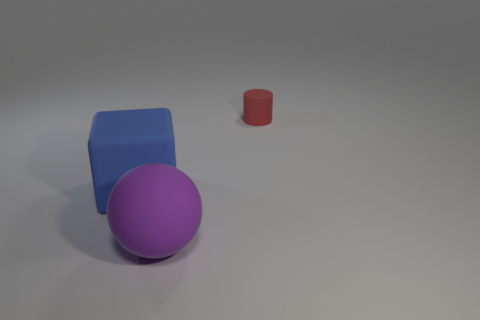There is a red thing that is made of the same material as the blue block; what size is it?
Your response must be concise. Small. What is the color of the rubber thing that is to the right of the big blue rubber object and to the left of the tiny red cylinder?
Make the answer very short. Purple. There is a big rubber object that is behind the ball; is its shape the same as the object that is behind the large blue object?
Provide a short and direct response. No. There is a thing that is right of the purple ball; what is its material?
Provide a short and direct response. Rubber. What number of things are either matte objects in front of the red thing or big blue cubes?
Your answer should be very brief. 2. Are there an equal number of purple spheres behind the big blue rubber thing and red cylinders?
Your answer should be very brief. No. Is the blue block the same size as the rubber cylinder?
Keep it short and to the point. No. There is a sphere that is the same size as the blue matte object; what is its color?
Offer a very short reply. Purple. There is a matte block; is it the same size as the matte thing right of the purple matte sphere?
Keep it short and to the point. No. What number of things are large purple matte spheres or matte objects left of the red rubber cylinder?
Provide a short and direct response. 2. 